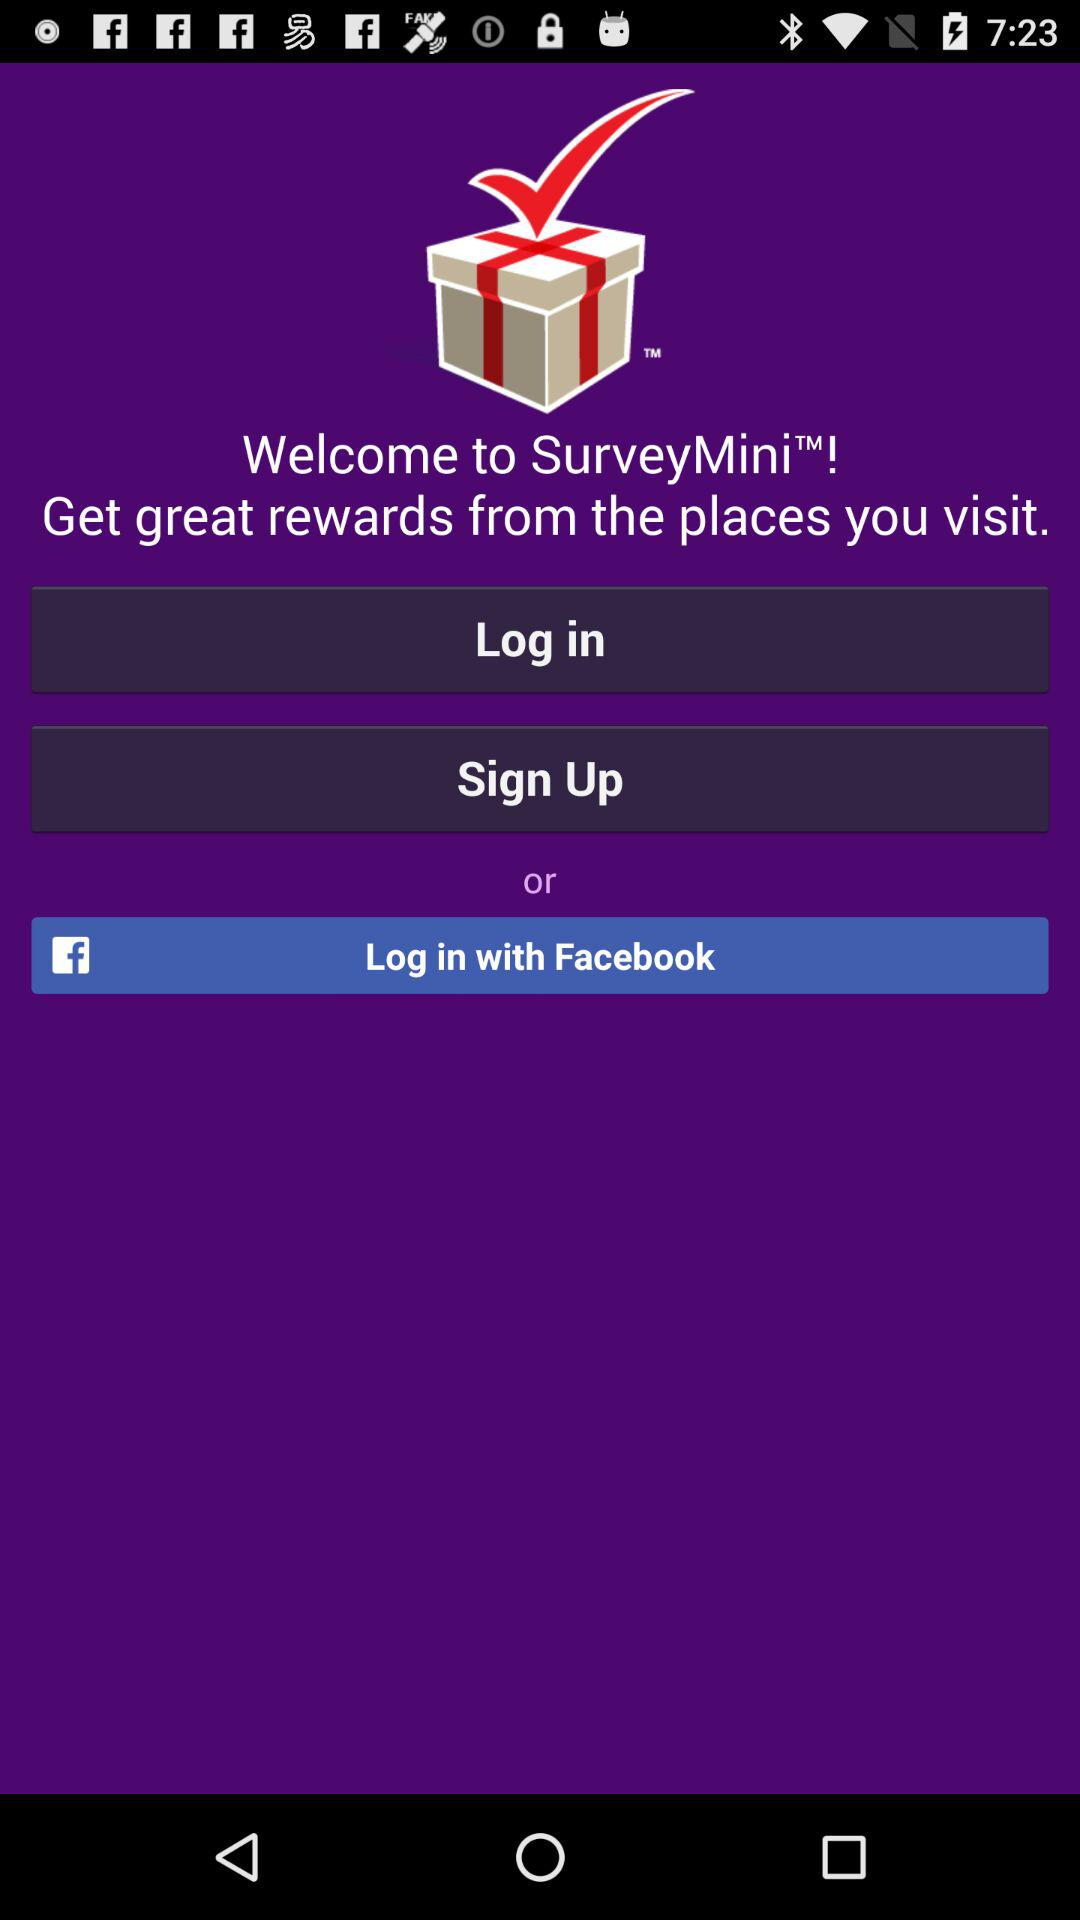What is the name of the application? The name of the application is "SurveyMini". 